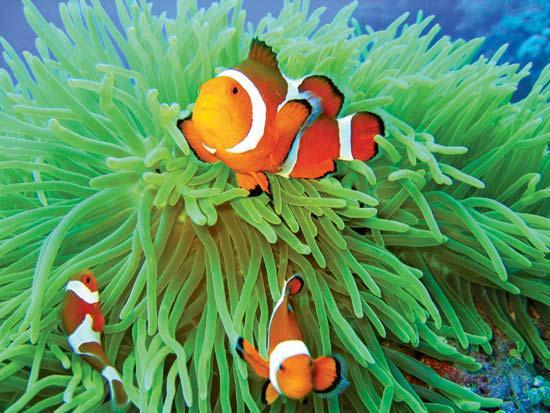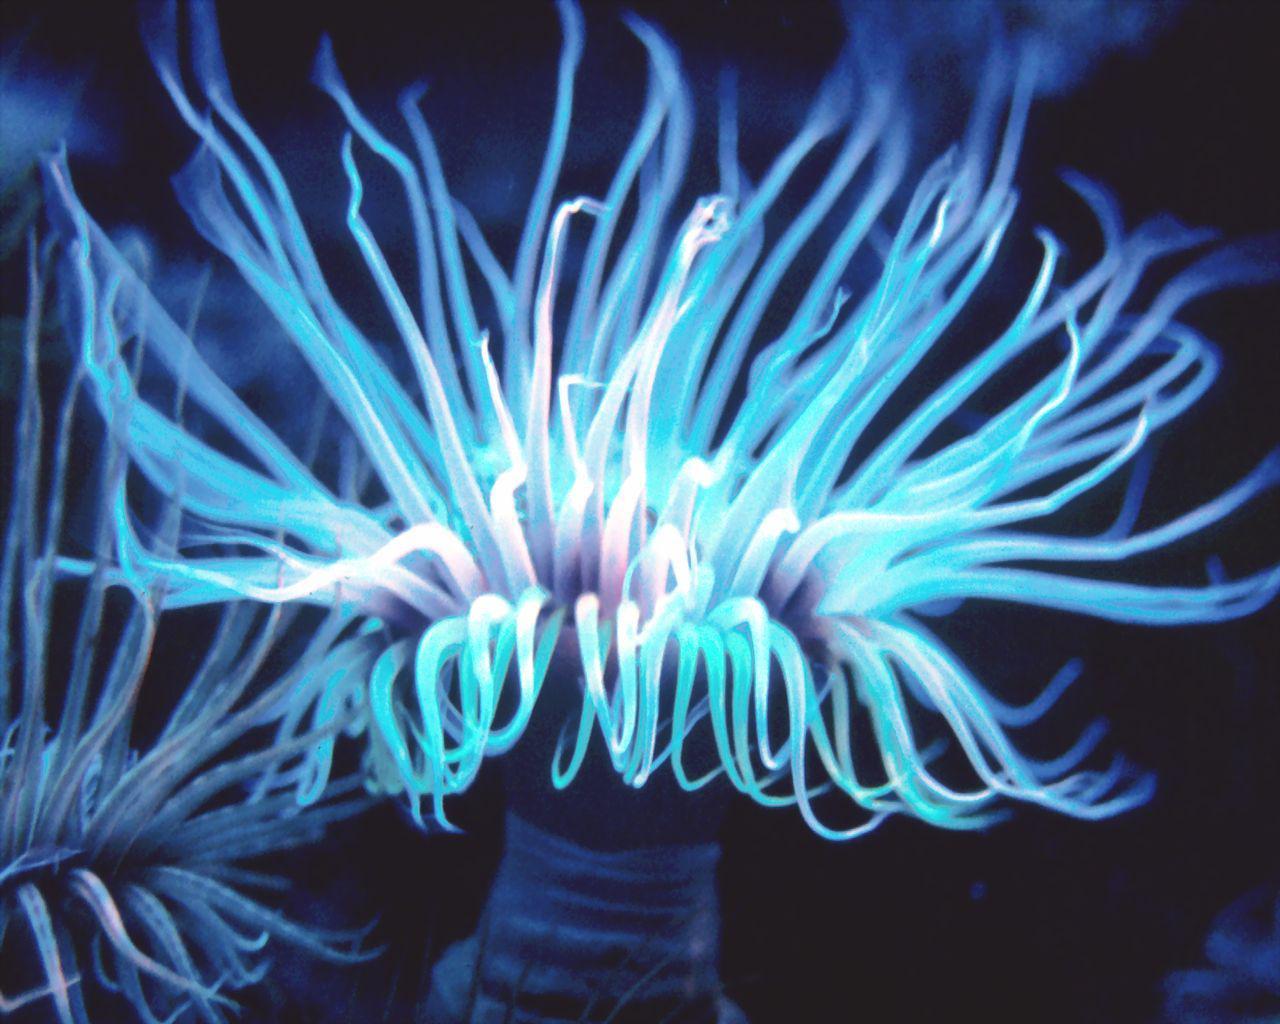The first image is the image on the left, the second image is the image on the right. Analyze the images presented: Is the assertion "Both images contain only sea anemones and rocks." valid? Answer yes or no. No. 